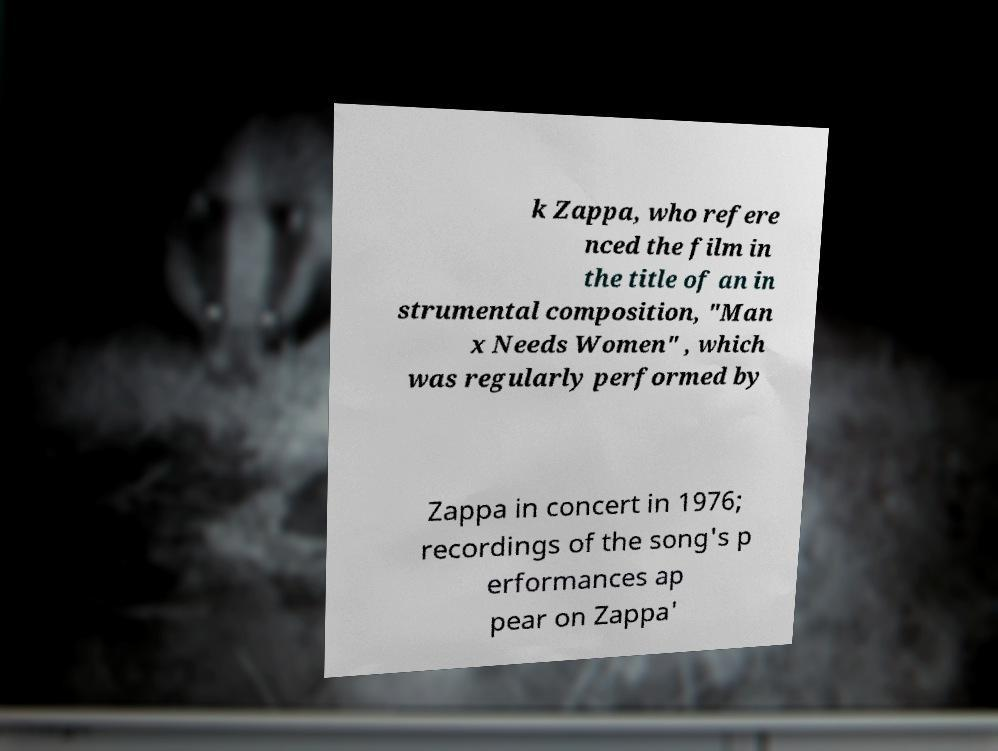Please read and relay the text visible in this image. What does it say? k Zappa, who refere nced the film in the title of an in strumental composition, "Man x Needs Women" , which was regularly performed by Zappa in concert in 1976; recordings of the song's p erformances ap pear on Zappa' 